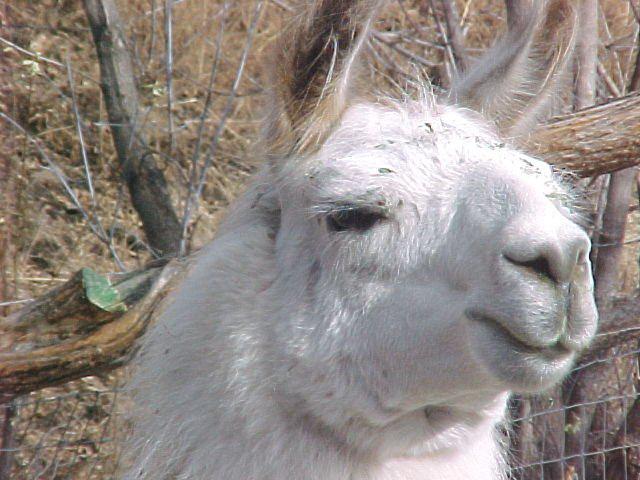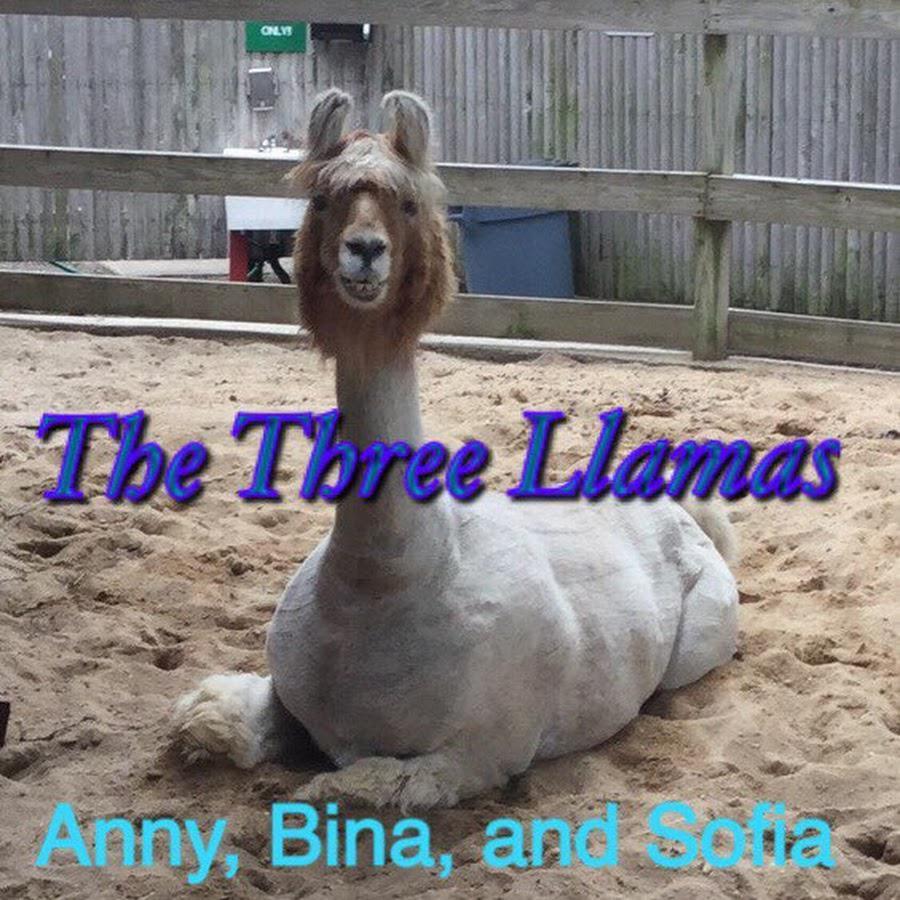The first image is the image on the left, the second image is the image on the right. For the images shown, is this caption "The left and right image contains the same number of Llamas." true? Answer yes or no. Yes. The first image is the image on the left, the second image is the image on the right. Evaluate the accuracy of this statement regarding the images: "One image shows three forward-facing llamas with non-shaggy faces, and the other image contains three llamas with shaggy wool.". Is it true? Answer yes or no. No. 